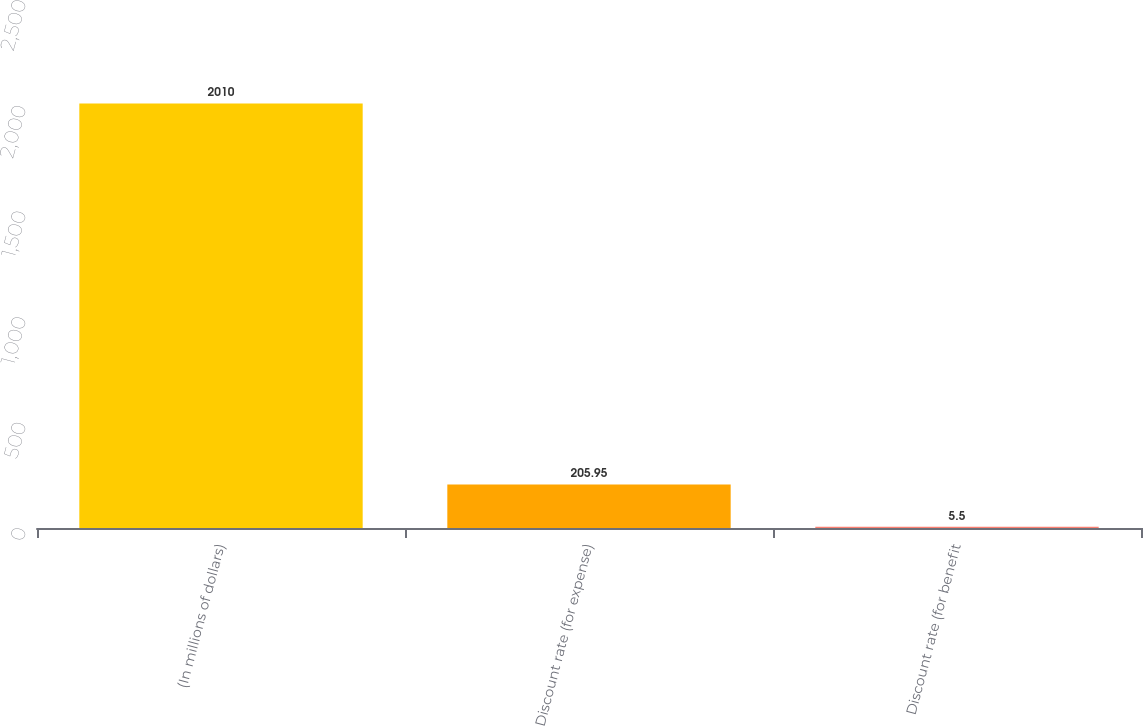Convert chart. <chart><loc_0><loc_0><loc_500><loc_500><bar_chart><fcel>(In millions of dollars)<fcel>Discount rate (for expense)<fcel>Discount rate (for benefit<nl><fcel>2010<fcel>205.95<fcel>5.5<nl></chart> 